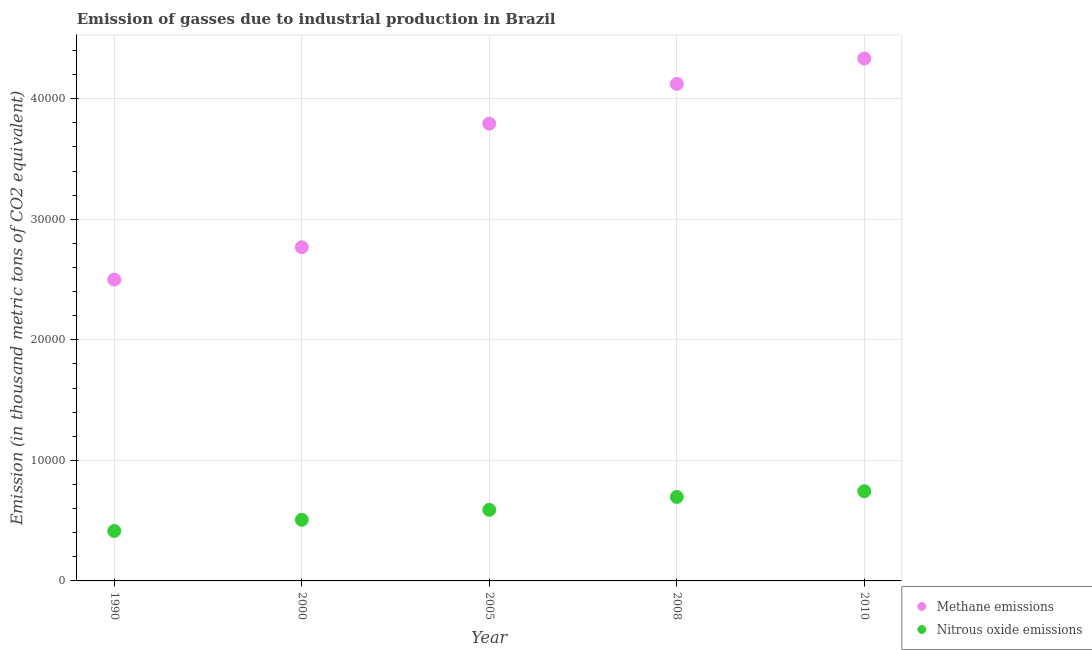How many different coloured dotlines are there?
Provide a short and direct response. 2. Is the number of dotlines equal to the number of legend labels?
Keep it short and to the point. Yes. What is the amount of methane emissions in 2008?
Your answer should be very brief. 4.12e+04. Across all years, what is the maximum amount of nitrous oxide emissions?
Your answer should be compact. 7440.7. Across all years, what is the minimum amount of methane emissions?
Ensure brevity in your answer.  2.50e+04. In which year was the amount of methane emissions minimum?
Your response must be concise. 1990. What is the total amount of methane emissions in the graph?
Your answer should be very brief. 1.75e+05. What is the difference between the amount of methane emissions in 2000 and that in 2008?
Offer a terse response. -1.36e+04. What is the difference between the amount of methane emissions in 2000 and the amount of nitrous oxide emissions in 2005?
Offer a terse response. 2.18e+04. What is the average amount of nitrous oxide emissions per year?
Provide a succinct answer. 5904.02. In the year 2008, what is the difference between the amount of methane emissions and amount of nitrous oxide emissions?
Ensure brevity in your answer.  3.43e+04. In how many years, is the amount of nitrous oxide emissions greater than 28000 thousand metric tons?
Provide a short and direct response. 0. What is the ratio of the amount of methane emissions in 1990 to that in 2010?
Keep it short and to the point. 0.58. Is the amount of methane emissions in 2000 less than that in 2005?
Keep it short and to the point. Yes. What is the difference between the highest and the second highest amount of nitrous oxide emissions?
Give a very brief answer. 472.8. What is the difference between the highest and the lowest amount of nitrous oxide emissions?
Provide a short and direct response. 3299.9. How many dotlines are there?
Offer a terse response. 2. Are the values on the major ticks of Y-axis written in scientific E-notation?
Ensure brevity in your answer.  No. Does the graph contain any zero values?
Your response must be concise. No. What is the title of the graph?
Offer a terse response. Emission of gasses due to industrial production in Brazil. Does "Transport services" appear as one of the legend labels in the graph?
Your answer should be very brief. No. What is the label or title of the Y-axis?
Your answer should be compact. Emission (in thousand metric tons of CO2 equivalent). What is the Emission (in thousand metric tons of CO2 equivalent) of Methane emissions in 1990?
Provide a short and direct response. 2.50e+04. What is the Emission (in thousand metric tons of CO2 equivalent) in Nitrous oxide emissions in 1990?
Provide a succinct answer. 4140.8. What is the Emission (in thousand metric tons of CO2 equivalent) of Methane emissions in 2000?
Keep it short and to the point. 2.77e+04. What is the Emission (in thousand metric tons of CO2 equivalent) in Nitrous oxide emissions in 2000?
Your response must be concise. 5073.4. What is the Emission (in thousand metric tons of CO2 equivalent) in Methane emissions in 2005?
Offer a terse response. 3.79e+04. What is the Emission (in thousand metric tons of CO2 equivalent) in Nitrous oxide emissions in 2005?
Offer a terse response. 5897.3. What is the Emission (in thousand metric tons of CO2 equivalent) in Methane emissions in 2008?
Provide a succinct answer. 4.12e+04. What is the Emission (in thousand metric tons of CO2 equivalent) of Nitrous oxide emissions in 2008?
Your response must be concise. 6967.9. What is the Emission (in thousand metric tons of CO2 equivalent) in Methane emissions in 2010?
Ensure brevity in your answer.  4.33e+04. What is the Emission (in thousand metric tons of CO2 equivalent) in Nitrous oxide emissions in 2010?
Ensure brevity in your answer.  7440.7. Across all years, what is the maximum Emission (in thousand metric tons of CO2 equivalent) of Methane emissions?
Your answer should be compact. 4.33e+04. Across all years, what is the maximum Emission (in thousand metric tons of CO2 equivalent) in Nitrous oxide emissions?
Your answer should be very brief. 7440.7. Across all years, what is the minimum Emission (in thousand metric tons of CO2 equivalent) in Methane emissions?
Your answer should be very brief. 2.50e+04. Across all years, what is the minimum Emission (in thousand metric tons of CO2 equivalent) of Nitrous oxide emissions?
Provide a succinct answer. 4140.8. What is the total Emission (in thousand metric tons of CO2 equivalent) in Methane emissions in the graph?
Provide a short and direct response. 1.75e+05. What is the total Emission (in thousand metric tons of CO2 equivalent) of Nitrous oxide emissions in the graph?
Your response must be concise. 2.95e+04. What is the difference between the Emission (in thousand metric tons of CO2 equivalent) of Methane emissions in 1990 and that in 2000?
Your response must be concise. -2683.2. What is the difference between the Emission (in thousand metric tons of CO2 equivalent) in Nitrous oxide emissions in 1990 and that in 2000?
Ensure brevity in your answer.  -932.6. What is the difference between the Emission (in thousand metric tons of CO2 equivalent) of Methane emissions in 1990 and that in 2005?
Your answer should be compact. -1.29e+04. What is the difference between the Emission (in thousand metric tons of CO2 equivalent) in Nitrous oxide emissions in 1990 and that in 2005?
Your answer should be very brief. -1756.5. What is the difference between the Emission (in thousand metric tons of CO2 equivalent) of Methane emissions in 1990 and that in 2008?
Keep it short and to the point. -1.62e+04. What is the difference between the Emission (in thousand metric tons of CO2 equivalent) of Nitrous oxide emissions in 1990 and that in 2008?
Ensure brevity in your answer.  -2827.1. What is the difference between the Emission (in thousand metric tons of CO2 equivalent) of Methane emissions in 1990 and that in 2010?
Provide a short and direct response. -1.83e+04. What is the difference between the Emission (in thousand metric tons of CO2 equivalent) of Nitrous oxide emissions in 1990 and that in 2010?
Your response must be concise. -3299.9. What is the difference between the Emission (in thousand metric tons of CO2 equivalent) of Methane emissions in 2000 and that in 2005?
Offer a terse response. -1.02e+04. What is the difference between the Emission (in thousand metric tons of CO2 equivalent) in Nitrous oxide emissions in 2000 and that in 2005?
Your answer should be compact. -823.9. What is the difference between the Emission (in thousand metric tons of CO2 equivalent) in Methane emissions in 2000 and that in 2008?
Give a very brief answer. -1.36e+04. What is the difference between the Emission (in thousand metric tons of CO2 equivalent) in Nitrous oxide emissions in 2000 and that in 2008?
Your answer should be compact. -1894.5. What is the difference between the Emission (in thousand metric tons of CO2 equivalent) of Methane emissions in 2000 and that in 2010?
Offer a very short reply. -1.57e+04. What is the difference between the Emission (in thousand metric tons of CO2 equivalent) of Nitrous oxide emissions in 2000 and that in 2010?
Make the answer very short. -2367.3. What is the difference between the Emission (in thousand metric tons of CO2 equivalent) in Methane emissions in 2005 and that in 2008?
Your answer should be compact. -3302.1. What is the difference between the Emission (in thousand metric tons of CO2 equivalent) in Nitrous oxide emissions in 2005 and that in 2008?
Your answer should be compact. -1070.6. What is the difference between the Emission (in thousand metric tons of CO2 equivalent) of Methane emissions in 2005 and that in 2010?
Make the answer very short. -5407.3. What is the difference between the Emission (in thousand metric tons of CO2 equivalent) of Nitrous oxide emissions in 2005 and that in 2010?
Make the answer very short. -1543.4. What is the difference between the Emission (in thousand metric tons of CO2 equivalent) of Methane emissions in 2008 and that in 2010?
Keep it short and to the point. -2105.2. What is the difference between the Emission (in thousand metric tons of CO2 equivalent) of Nitrous oxide emissions in 2008 and that in 2010?
Give a very brief answer. -472.8. What is the difference between the Emission (in thousand metric tons of CO2 equivalent) in Methane emissions in 1990 and the Emission (in thousand metric tons of CO2 equivalent) in Nitrous oxide emissions in 2000?
Your answer should be very brief. 1.99e+04. What is the difference between the Emission (in thousand metric tons of CO2 equivalent) in Methane emissions in 1990 and the Emission (in thousand metric tons of CO2 equivalent) in Nitrous oxide emissions in 2005?
Make the answer very short. 1.91e+04. What is the difference between the Emission (in thousand metric tons of CO2 equivalent) in Methane emissions in 1990 and the Emission (in thousand metric tons of CO2 equivalent) in Nitrous oxide emissions in 2008?
Make the answer very short. 1.80e+04. What is the difference between the Emission (in thousand metric tons of CO2 equivalent) in Methane emissions in 1990 and the Emission (in thousand metric tons of CO2 equivalent) in Nitrous oxide emissions in 2010?
Provide a succinct answer. 1.76e+04. What is the difference between the Emission (in thousand metric tons of CO2 equivalent) in Methane emissions in 2000 and the Emission (in thousand metric tons of CO2 equivalent) in Nitrous oxide emissions in 2005?
Your answer should be very brief. 2.18e+04. What is the difference between the Emission (in thousand metric tons of CO2 equivalent) in Methane emissions in 2000 and the Emission (in thousand metric tons of CO2 equivalent) in Nitrous oxide emissions in 2008?
Offer a terse response. 2.07e+04. What is the difference between the Emission (in thousand metric tons of CO2 equivalent) of Methane emissions in 2000 and the Emission (in thousand metric tons of CO2 equivalent) of Nitrous oxide emissions in 2010?
Provide a short and direct response. 2.02e+04. What is the difference between the Emission (in thousand metric tons of CO2 equivalent) in Methane emissions in 2005 and the Emission (in thousand metric tons of CO2 equivalent) in Nitrous oxide emissions in 2008?
Provide a short and direct response. 3.10e+04. What is the difference between the Emission (in thousand metric tons of CO2 equivalent) in Methane emissions in 2005 and the Emission (in thousand metric tons of CO2 equivalent) in Nitrous oxide emissions in 2010?
Offer a terse response. 3.05e+04. What is the difference between the Emission (in thousand metric tons of CO2 equivalent) in Methane emissions in 2008 and the Emission (in thousand metric tons of CO2 equivalent) in Nitrous oxide emissions in 2010?
Your answer should be compact. 3.38e+04. What is the average Emission (in thousand metric tons of CO2 equivalent) of Methane emissions per year?
Ensure brevity in your answer.  3.50e+04. What is the average Emission (in thousand metric tons of CO2 equivalent) of Nitrous oxide emissions per year?
Provide a succinct answer. 5904.02. In the year 1990, what is the difference between the Emission (in thousand metric tons of CO2 equivalent) in Methane emissions and Emission (in thousand metric tons of CO2 equivalent) in Nitrous oxide emissions?
Ensure brevity in your answer.  2.09e+04. In the year 2000, what is the difference between the Emission (in thousand metric tons of CO2 equivalent) in Methane emissions and Emission (in thousand metric tons of CO2 equivalent) in Nitrous oxide emissions?
Offer a terse response. 2.26e+04. In the year 2005, what is the difference between the Emission (in thousand metric tons of CO2 equivalent) in Methane emissions and Emission (in thousand metric tons of CO2 equivalent) in Nitrous oxide emissions?
Your answer should be compact. 3.20e+04. In the year 2008, what is the difference between the Emission (in thousand metric tons of CO2 equivalent) in Methane emissions and Emission (in thousand metric tons of CO2 equivalent) in Nitrous oxide emissions?
Provide a succinct answer. 3.43e+04. In the year 2010, what is the difference between the Emission (in thousand metric tons of CO2 equivalent) of Methane emissions and Emission (in thousand metric tons of CO2 equivalent) of Nitrous oxide emissions?
Ensure brevity in your answer.  3.59e+04. What is the ratio of the Emission (in thousand metric tons of CO2 equivalent) in Methane emissions in 1990 to that in 2000?
Provide a short and direct response. 0.9. What is the ratio of the Emission (in thousand metric tons of CO2 equivalent) in Nitrous oxide emissions in 1990 to that in 2000?
Provide a succinct answer. 0.82. What is the ratio of the Emission (in thousand metric tons of CO2 equivalent) of Methane emissions in 1990 to that in 2005?
Keep it short and to the point. 0.66. What is the ratio of the Emission (in thousand metric tons of CO2 equivalent) in Nitrous oxide emissions in 1990 to that in 2005?
Give a very brief answer. 0.7. What is the ratio of the Emission (in thousand metric tons of CO2 equivalent) of Methane emissions in 1990 to that in 2008?
Provide a short and direct response. 0.61. What is the ratio of the Emission (in thousand metric tons of CO2 equivalent) of Nitrous oxide emissions in 1990 to that in 2008?
Your answer should be compact. 0.59. What is the ratio of the Emission (in thousand metric tons of CO2 equivalent) in Methane emissions in 1990 to that in 2010?
Keep it short and to the point. 0.58. What is the ratio of the Emission (in thousand metric tons of CO2 equivalent) of Nitrous oxide emissions in 1990 to that in 2010?
Keep it short and to the point. 0.56. What is the ratio of the Emission (in thousand metric tons of CO2 equivalent) in Methane emissions in 2000 to that in 2005?
Give a very brief answer. 0.73. What is the ratio of the Emission (in thousand metric tons of CO2 equivalent) of Nitrous oxide emissions in 2000 to that in 2005?
Your answer should be very brief. 0.86. What is the ratio of the Emission (in thousand metric tons of CO2 equivalent) of Methane emissions in 2000 to that in 2008?
Keep it short and to the point. 0.67. What is the ratio of the Emission (in thousand metric tons of CO2 equivalent) of Nitrous oxide emissions in 2000 to that in 2008?
Your answer should be compact. 0.73. What is the ratio of the Emission (in thousand metric tons of CO2 equivalent) in Methane emissions in 2000 to that in 2010?
Provide a succinct answer. 0.64. What is the ratio of the Emission (in thousand metric tons of CO2 equivalent) in Nitrous oxide emissions in 2000 to that in 2010?
Keep it short and to the point. 0.68. What is the ratio of the Emission (in thousand metric tons of CO2 equivalent) of Methane emissions in 2005 to that in 2008?
Make the answer very short. 0.92. What is the ratio of the Emission (in thousand metric tons of CO2 equivalent) in Nitrous oxide emissions in 2005 to that in 2008?
Offer a very short reply. 0.85. What is the ratio of the Emission (in thousand metric tons of CO2 equivalent) of Methane emissions in 2005 to that in 2010?
Provide a short and direct response. 0.88. What is the ratio of the Emission (in thousand metric tons of CO2 equivalent) of Nitrous oxide emissions in 2005 to that in 2010?
Your answer should be compact. 0.79. What is the ratio of the Emission (in thousand metric tons of CO2 equivalent) in Methane emissions in 2008 to that in 2010?
Your answer should be compact. 0.95. What is the ratio of the Emission (in thousand metric tons of CO2 equivalent) in Nitrous oxide emissions in 2008 to that in 2010?
Your answer should be compact. 0.94. What is the difference between the highest and the second highest Emission (in thousand metric tons of CO2 equivalent) in Methane emissions?
Provide a succinct answer. 2105.2. What is the difference between the highest and the second highest Emission (in thousand metric tons of CO2 equivalent) of Nitrous oxide emissions?
Your response must be concise. 472.8. What is the difference between the highest and the lowest Emission (in thousand metric tons of CO2 equivalent) of Methane emissions?
Ensure brevity in your answer.  1.83e+04. What is the difference between the highest and the lowest Emission (in thousand metric tons of CO2 equivalent) in Nitrous oxide emissions?
Make the answer very short. 3299.9. 